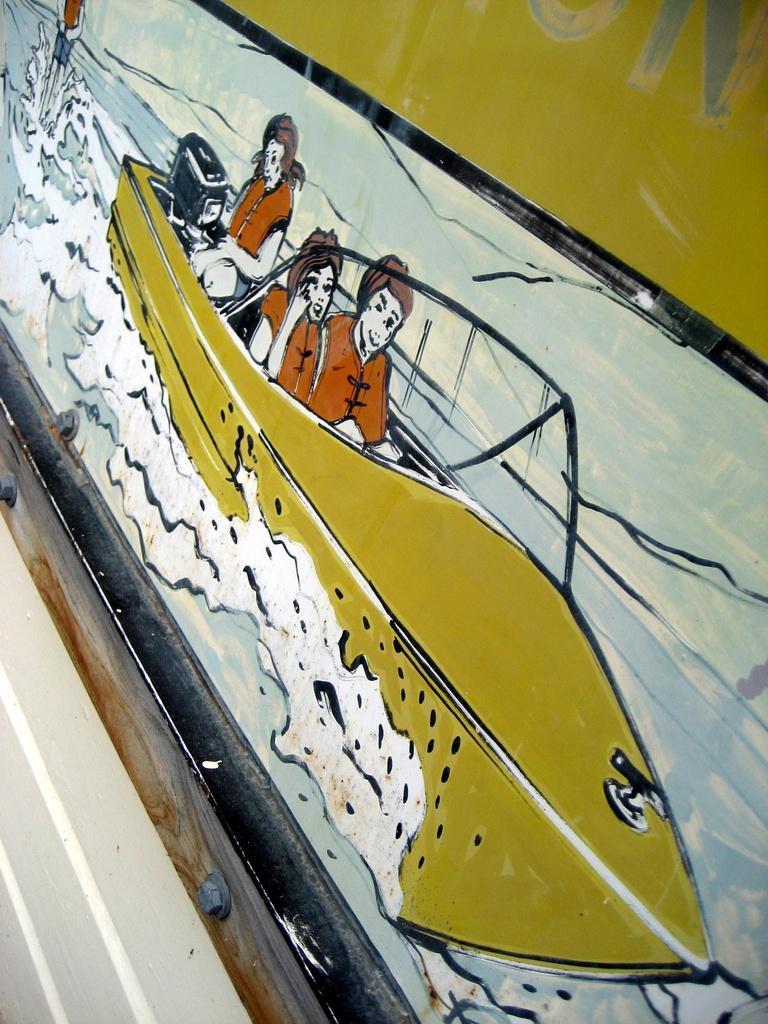Could you give a brief overview of what you see in this image? This is a painting. Here we can see a boat, water, and three persons. 